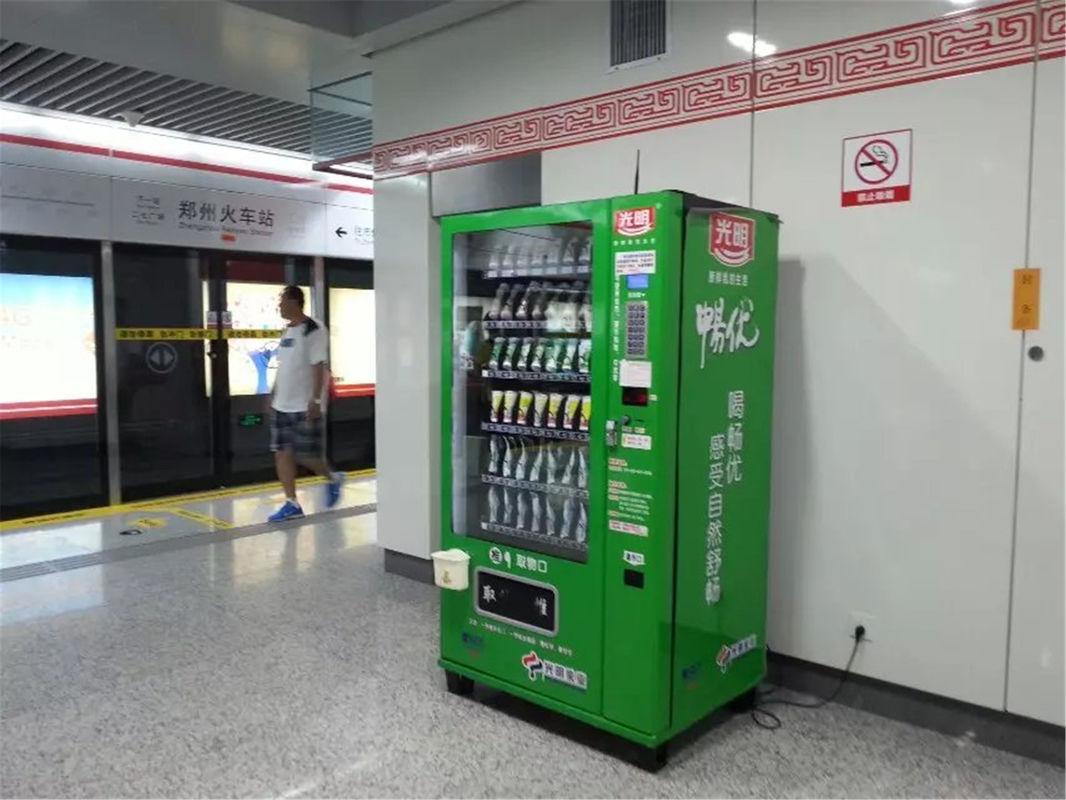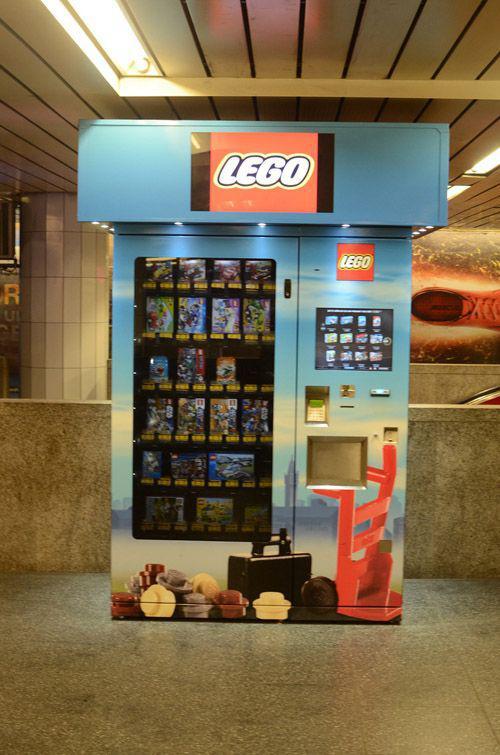The first image is the image on the left, the second image is the image on the right. Given the left and right images, does the statement "There's the same number of vending machines in each image." hold true? Answer yes or no. Yes. 